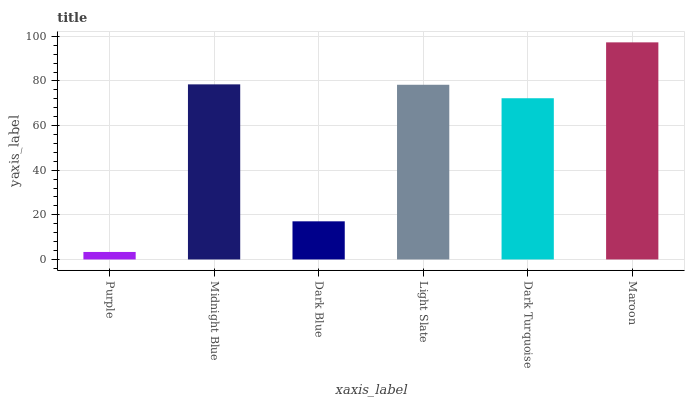Is Midnight Blue the minimum?
Answer yes or no. No. Is Midnight Blue the maximum?
Answer yes or no. No. Is Midnight Blue greater than Purple?
Answer yes or no. Yes. Is Purple less than Midnight Blue?
Answer yes or no. Yes. Is Purple greater than Midnight Blue?
Answer yes or no. No. Is Midnight Blue less than Purple?
Answer yes or no. No. Is Light Slate the high median?
Answer yes or no. Yes. Is Dark Turquoise the low median?
Answer yes or no. Yes. Is Dark Turquoise the high median?
Answer yes or no. No. Is Purple the low median?
Answer yes or no. No. 